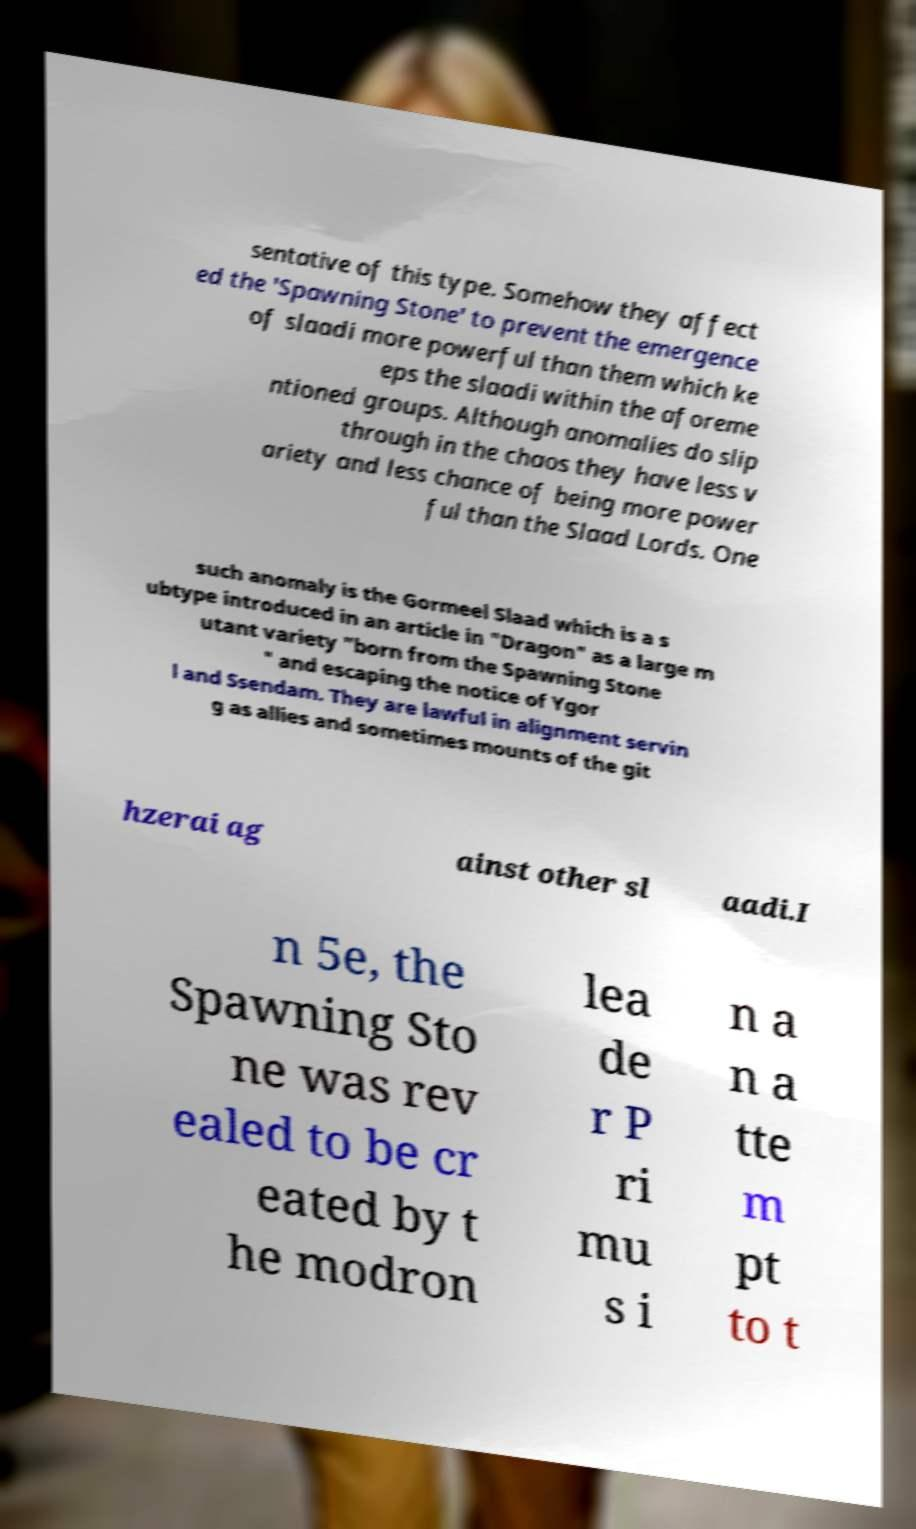Could you extract and type out the text from this image? sentative of this type. Somehow they affect ed the 'Spawning Stone' to prevent the emergence of slaadi more powerful than them which ke eps the slaadi within the aforeme ntioned groups. Although anomalies do slip through in the chaos they have less v ariety and less chance of being more power ful than the Slaad Lords. One such anomaly is the Gormeel Slaad which is a s ubtype introduced in an article in "Dragon" as a large m utant variety "born from the Spawning Stone " and escaping the notice of Ygor l and Ssendam. They are lawful in alignment servin g as allies and sometimes mounts of the git hzerai ag ainst other sl aadi.I n 5e, the Spawning Sto ne was rev ealed to be cr eated by t he modron lea de r P ri mu s i n a n a tte m pt to t 